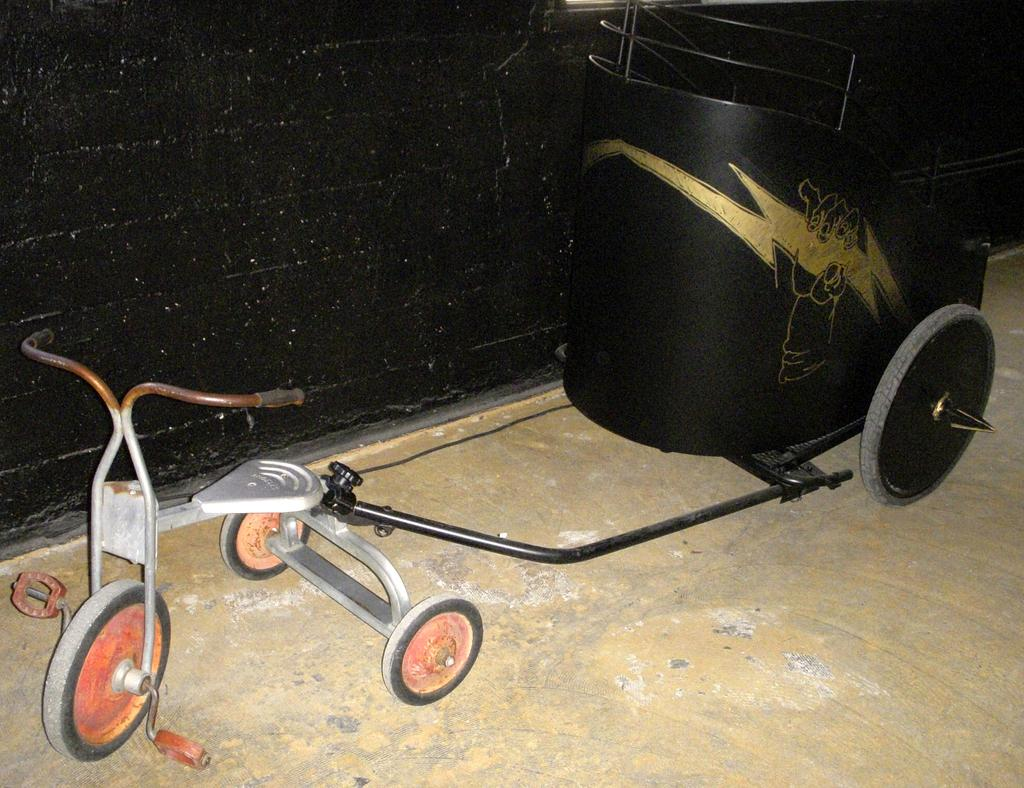What is the main object in the image? There is a cart in the image. What else can be seen in the image? There is a wall in the image. What type of poison is being used by the spy in the image? There is no poison, spy, or any related activity depicted in the image. 